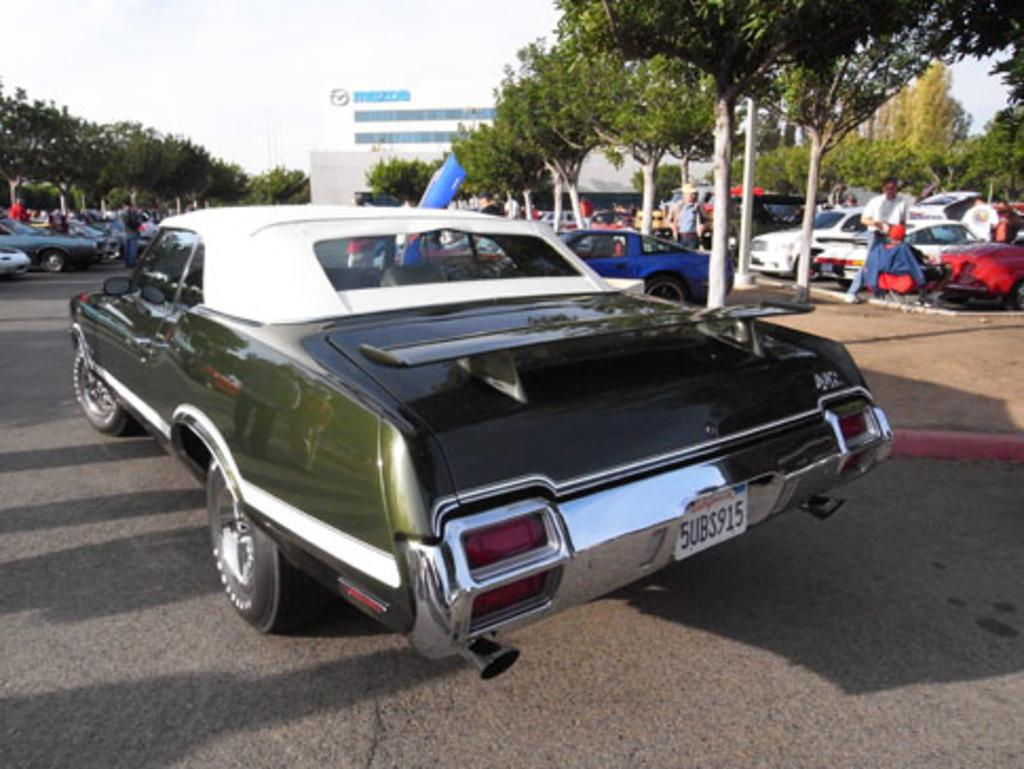What can be seen on the road in the image? There are vehicles on the road in the image. What is visible in the background of the image? There are trees and buildings in the background of the image. What else can be seen in the image besides the vehicles and background? There are poles visible in the image. Are there any living beings present in the image? Yes, there are people in the image. What is visible at the top of the image? The sky is visible at the top of the image. Can you tell me where the tramp is located in the image? There is no tramp present in the image. What type of place is depicted in the image? The image does not depict a specific type of place; it shows a road with vehicles, trees, buildings, poles, and people. 